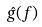Convert formula to latex. <formula><loc_0><loc_0><loc_500><loc_500>\hat { g } ( f )</formula> 